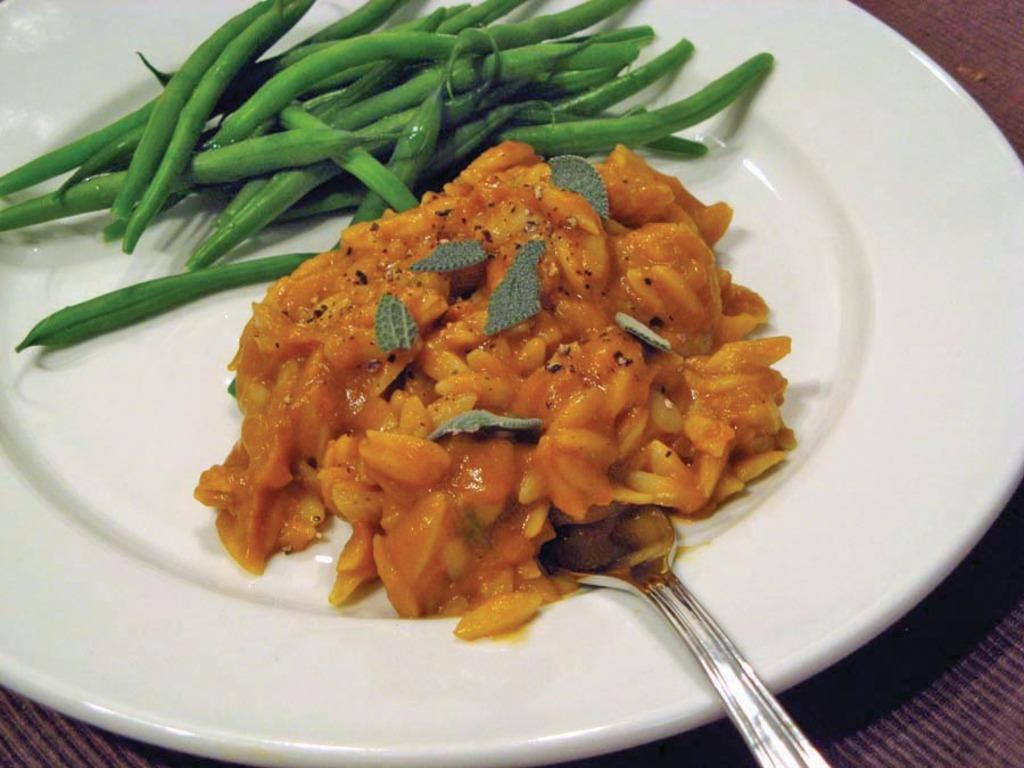What is on the surface in the image? There is a white plate on the surface in the image. What is on the plate? There is food on the plate. What utensil is present in the image? There is a spoon in the image. What type of plants can be seen growing on the plate in the image? There are no plants visible on the plate in the image; it contains food. How does the bread increase in size in the image? There is no bread present in the image, so it cannot increase in size. 